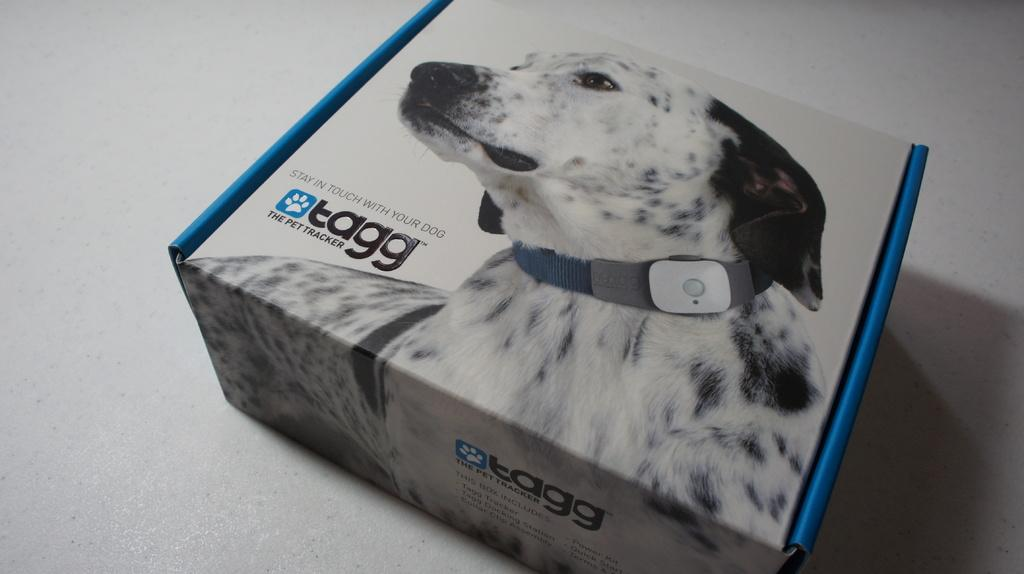<image>
Render a clear and concise summary of the photo. The box shows a special collar for a dog called the Tagg. 